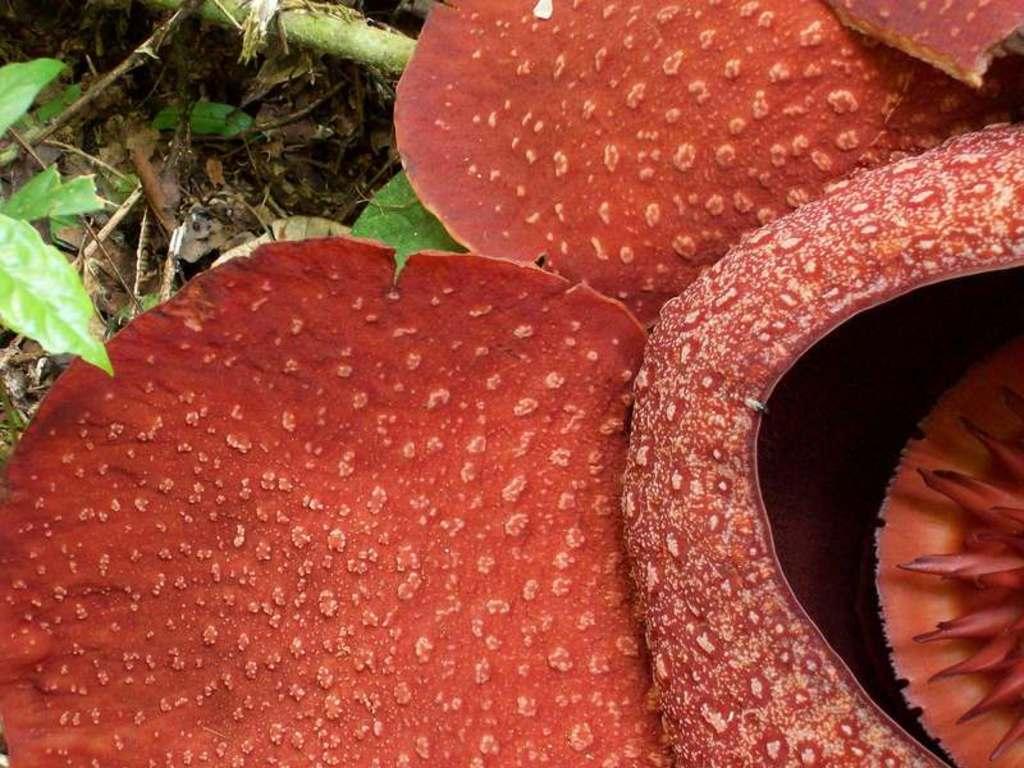In one or two sentences, can you explain what this image depicts? In this image, I can see house plants and grass on the ground. This image is taken, maybe during a day. 